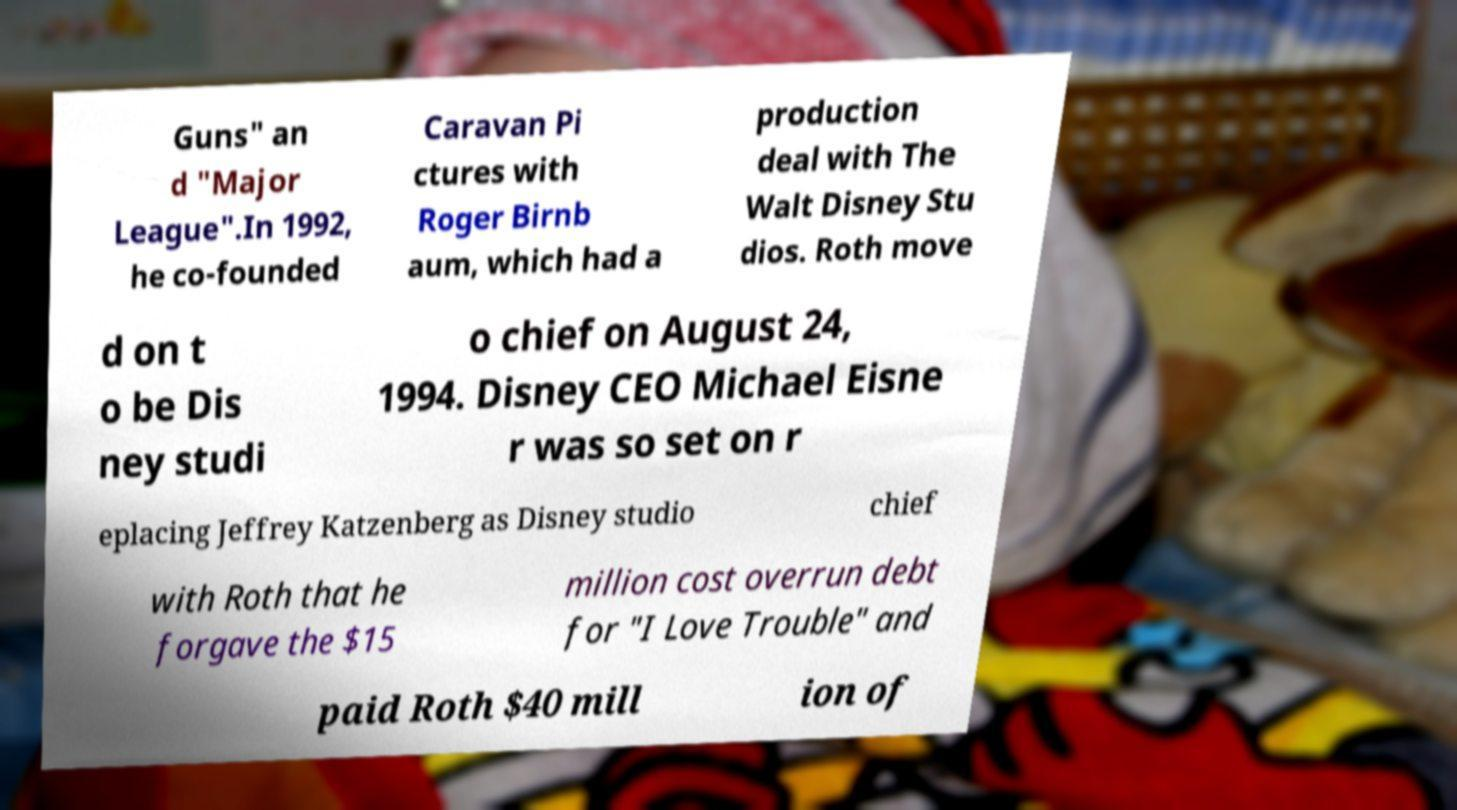There's text embedded in this image that I need extracted. Can you transcribe it verbatim? Guns" an d "Major League".In 1992, he co-founded Caravan Pi ctures with Roger Birnb aum, which had a production deal with The Walt Disney Stu dios. Roth move d on t o be Dis ney studi o chief on August 24, 1994. Disney CEO Michael Eisne r was so set on r eplacing Jeffrey Katzenberg as Disney studio chief with Roth that he forgave the $15 million cost overrun debt for "I Love Trouble" and paid Roth $40 mill ion of 